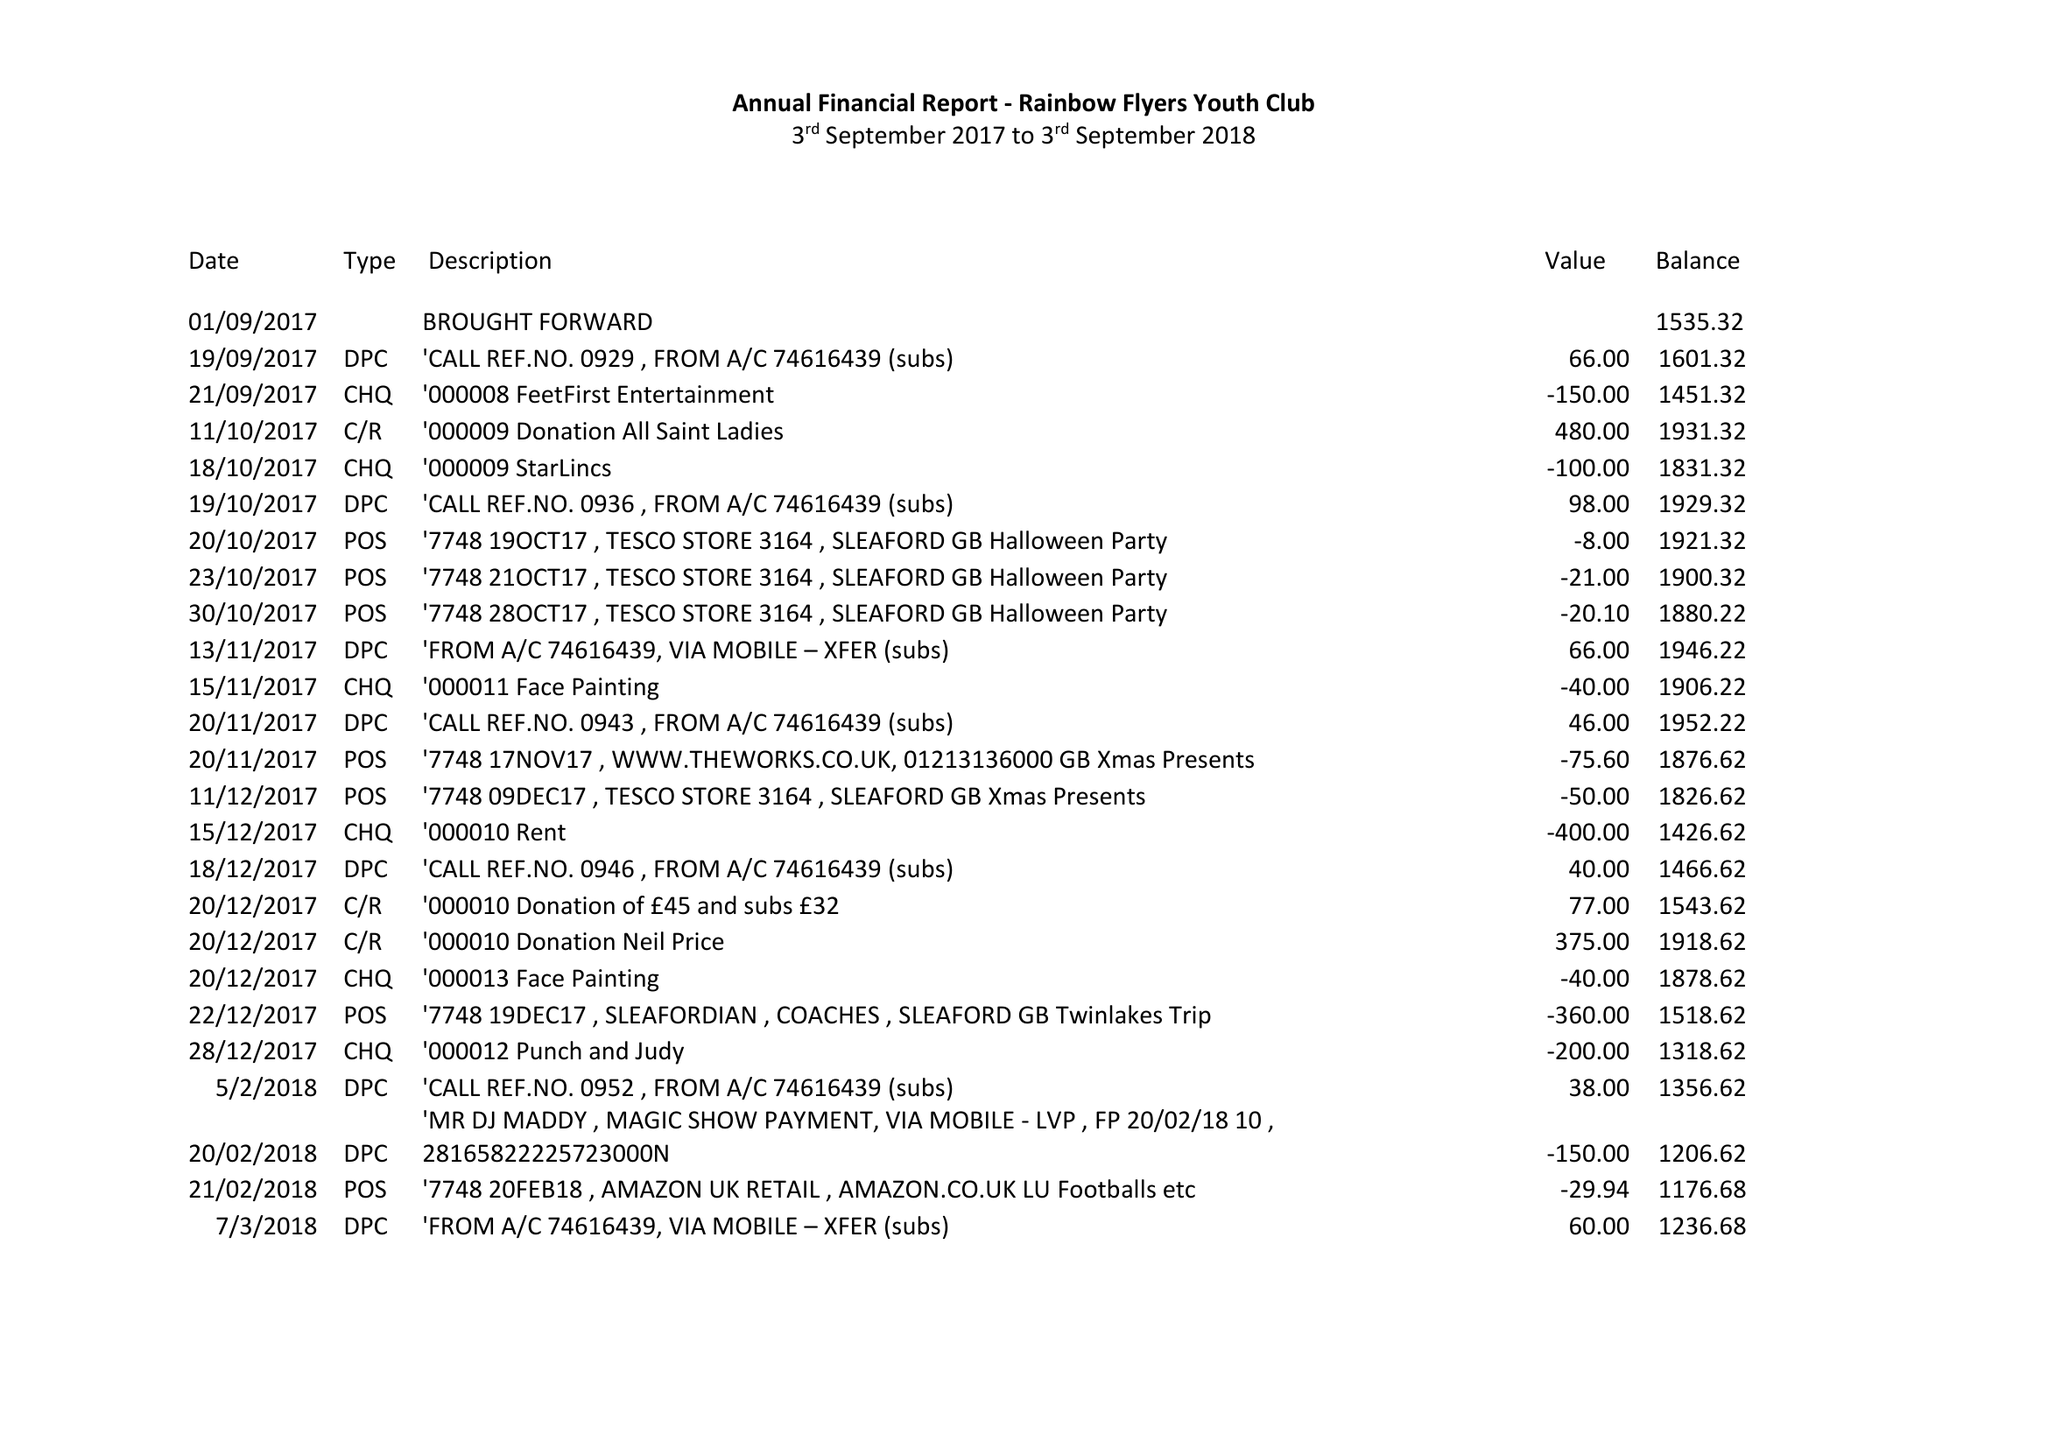What is the value for the charity_number?
Answer the question using a single word or phrase. 1170051 